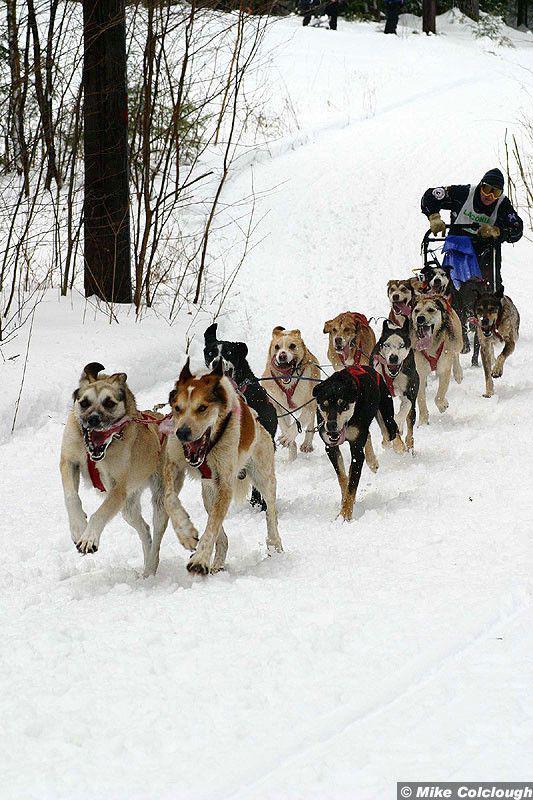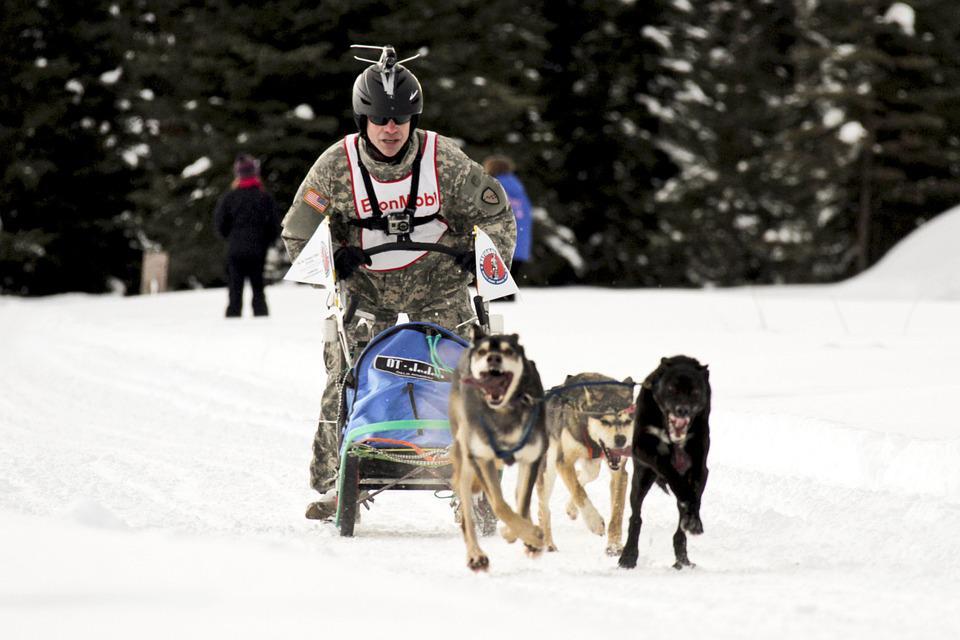The first image is the image on the left, the second image is the image on the right. Examine the images to the left and right. Is the description "Two light colored dogs are pulling a sled in one of the images." accurate? Answer yes or no. No. The first image is the image on the left, the second image is the image on the right. For the images shown, is this caption "There are at least two people sitting down riding a sled." true? Answer yes or no. No. 